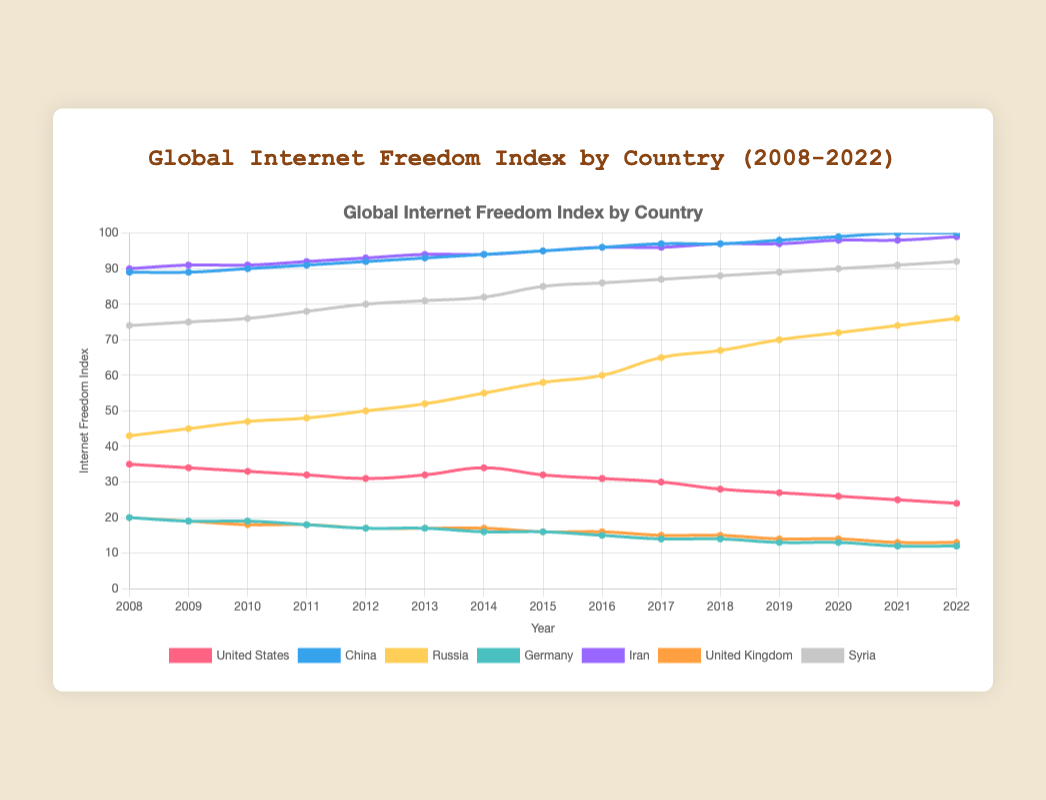Which country had the highest Internet Freedom Index in 2022? By observing the chart, we can see that China and Iran have the highest Internet Freedom Index values, both at 100. So, we can say the countries with highest index in 2022 are China and Iran.
Answer: China, Iran What was the average Internet Freedom Index of Russia from 2010 to 2020? First, extract the values of Russia from 2010 to 2020: 47, 48, 50, 52, 55, 58, 60, 65, 67, 70. Sum these values: 47 + 48 + 50 + 52 + 55 + 58 + 60 + 65 + 67 + 70 = 572. Then, divide by the number of years (11): 572 / 11 = 57.2.
Answer: 57.2 How did the Internet Freedom Index of Germany change from 2008 to 2022? In 2008, Germany's index was 20, and in 2022 it was 12. The change is 20 - 12 = 8, so it decreased by 8 points.
Answer: Decreased by 8 points Which country had the smallest difference in Internet Freedom Index between 2008 and 2022? By observing the chart, we need to examine the differences for each country: 
United States (35 - 24 = 11), 
China (89 - 100 = -11), 
Russia (43 - 76 = -33), 
Germany (20 - 12 = 8), 
Iran (90 - 99 = -9), 
United Kingdom (20 - 13 = 7), 
Syria (74 - 92 = -18). The smallest difference is for the United Kingdom with a difference of 7.
Answer: United Kingdom Which countries had an Internet Freedom Index of 100 in any of the years shown? By observing the chart, China and Iran both reached an index of 100. This can be seen in the latter years such as 2021 and 2022.
Answer: China, Iran During which year did the United States show its largest yearly decline in the Internet Freedom Index? By examining the year-by-year values for the United States, the largest yearly decline occurs between 2017 (30) and 2018 (28), with a decline of 30 - 28 = 2 points.
Answer: 2018 Compare the indexes of Syria and Russia in 2015. Which country had a higher index and by how much? By looking at the chart, Syria's index in 2015 was 85, and Russia's was 58. Syria's index was higher by 85 - 58 = 27 points.
Answer: Syria by 27 points Which country had the most consistent (i.e., least varying) Internet Freedom Index over the given time period? Germany shows the least variation in its Internet Freedom Index as the values vary minimally from 20 in 2008 to 12 in 2022, indicating a consistent trend compared to other countries.
Answer: Germany What was the combined Internet Freedom Index of the United States and the United Kingdom in 2009? The index for the United States in 2009 was 34, and for the United Kingdom, it was 19. Their combined index in 2009 is 34 + 19 = 53.
Answer: 53 